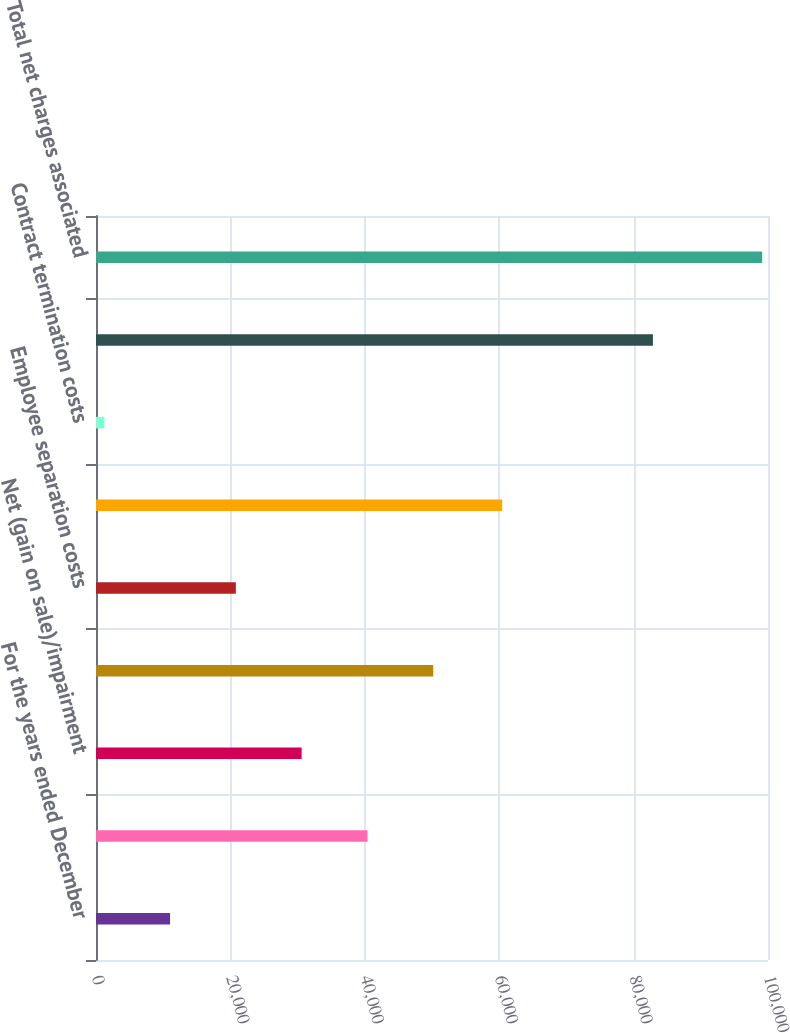Convert chart. <chart><loc_0><loc_0><loc_500><loc_500><bar_chart><fcel>For the years ended December<fcel>Global supply chain<fcel>Net (gain on sale)/impairment<fcel>Plant closure expense<fcel>Employee separation costs<fcel>Pension settlement loss<fcel>Contract termination costs<fcel>Total business realignment and<fcel>Total net charges associated<nl><fcel>11021<fcel>40391<fcel>30601<fcel>50181<fcel>20811<fcel>60431<fcel>1231<fcel>82875<fcel>99131<nl></chart> 